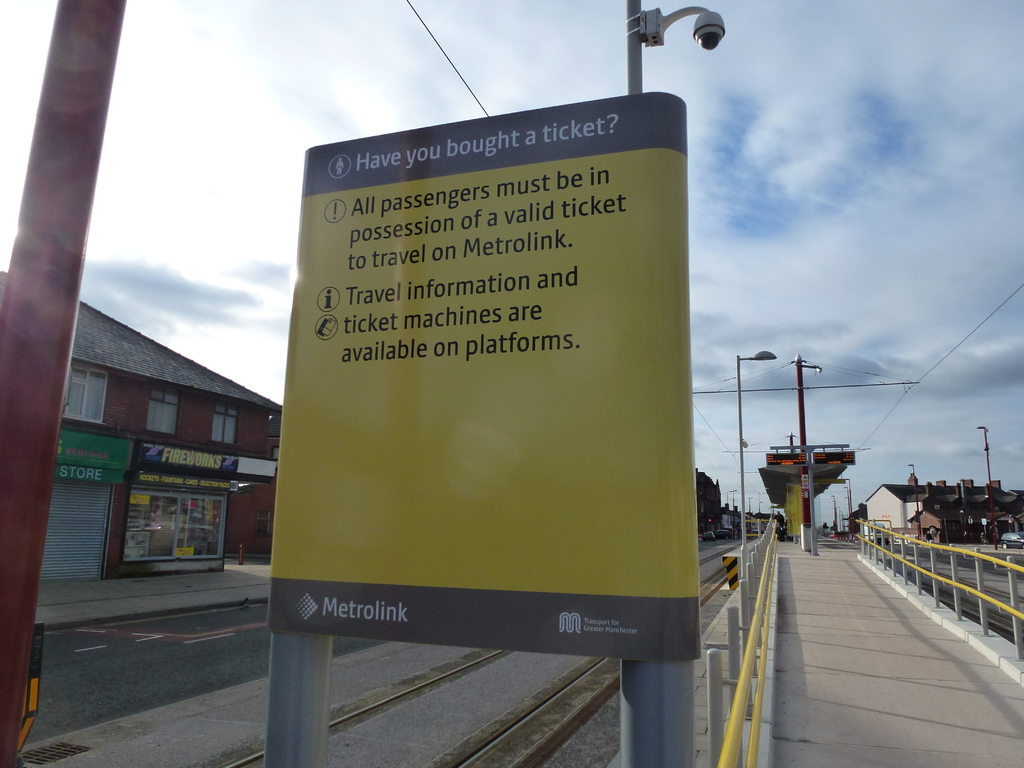What's happening in the scene? The image captures a scene at a Metrolink station, where a yellow sign stands prominently. The sign serves as a reminder for passengers, stating "Have you bought a ticket? All passengers must be in possession of a valid ticket to travel on Metrolink." It further informs that travel information and ticket machines are available on platforms. The Metrolink logo is displayed at the bottom of the sign, affirming the authority of the message. The sign is mounted on a gray pole, and the backdrop features a street with buildings under a blue sky, painting a typical day at the Metrolink station. 